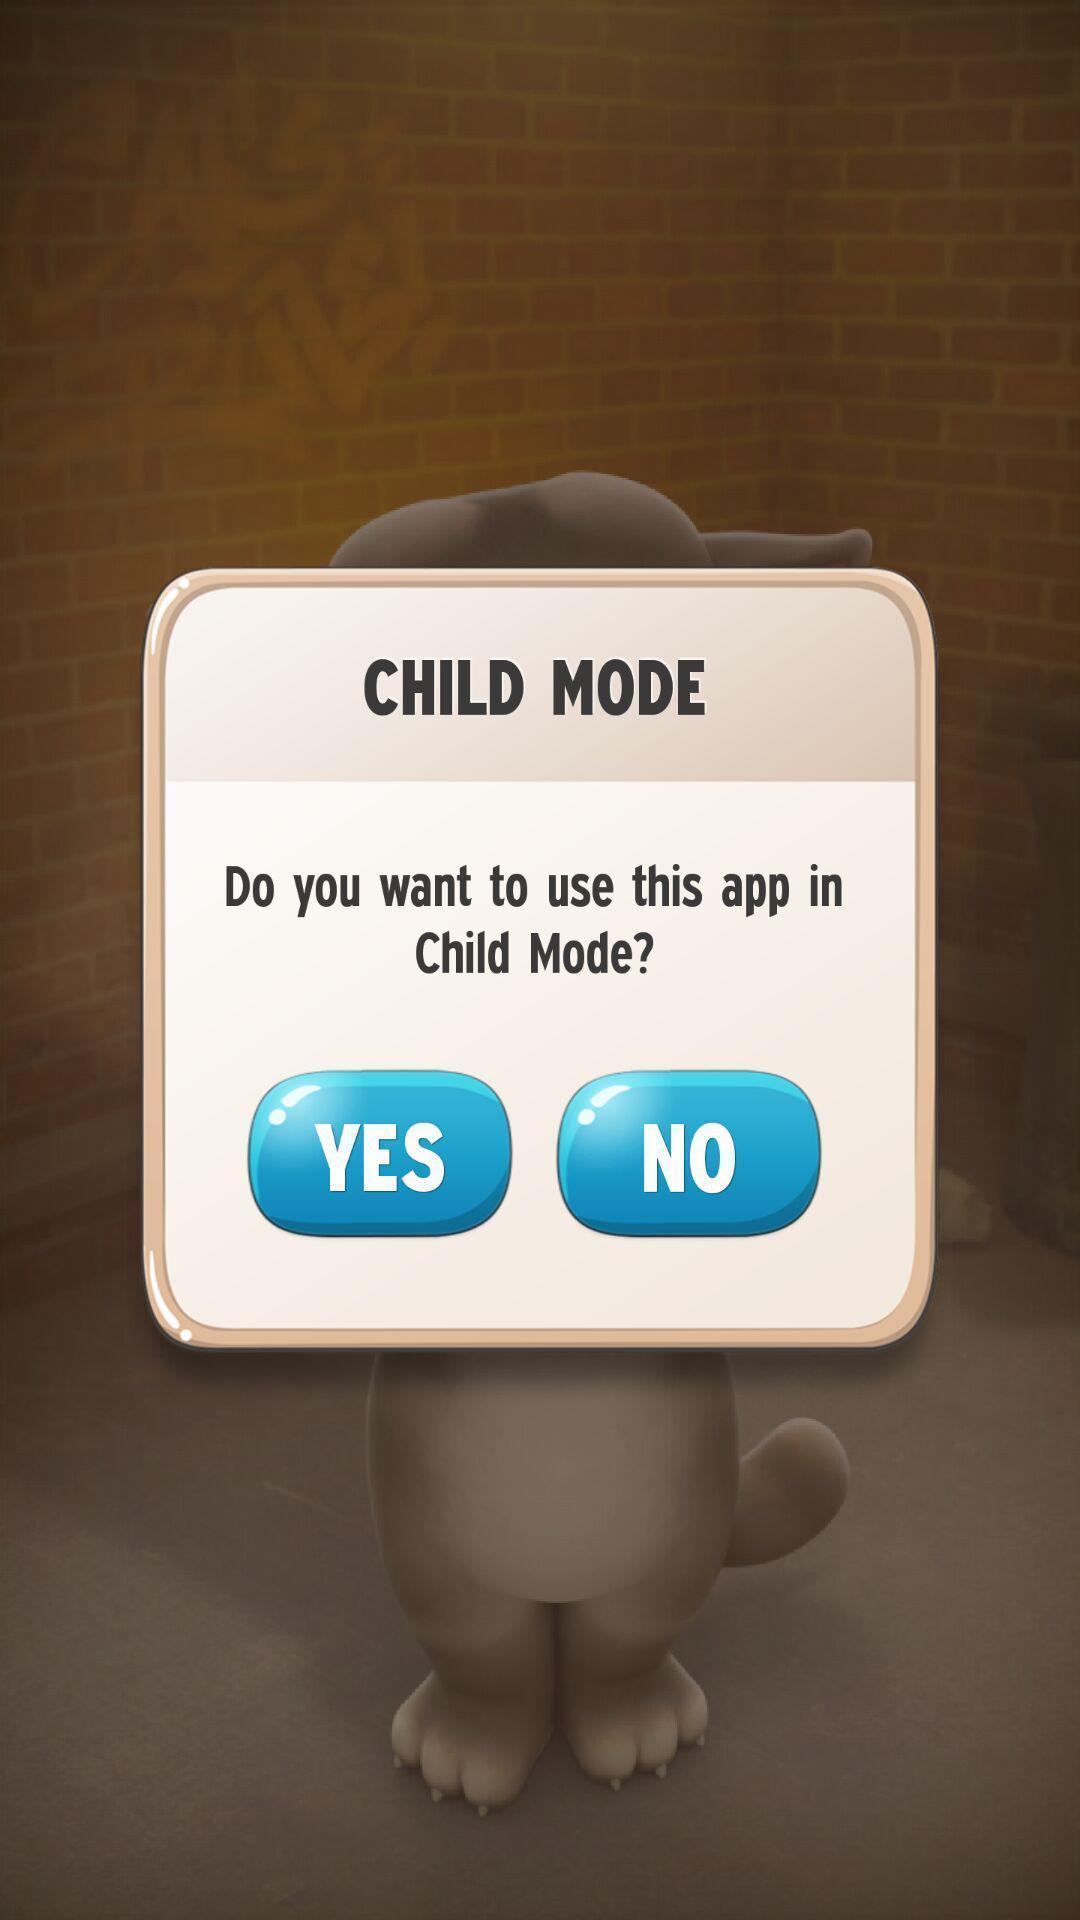What is the overall content of this screenshot? Popup displaying about child mode. 